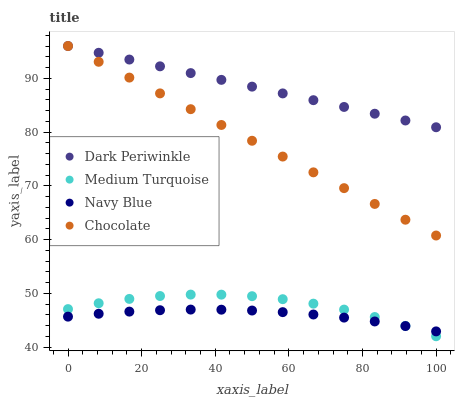Does Navy Blue have the minimum area under the curve?
Answer yes or no. Yes. Does Dark Periwinkle have the maximum area under the curve?
Answer yes or no. Yes. Does Medium Turquoise have the minimum area under the curve?
Answer yes or no. No. Does Medium Turquoise have the maximum area under the curve?
Answer yes or no. No. Is Dark Periwinkle the smoothest?
Answer yes or no. Yes. Is Medium Turquoise the roughest?
Answer yes or no. Yes. Is Medium Turquoise the smoothest?
Answer yes or no. No. Is Dark Periwinkle the roughest?
Answer yes or no. No. Does Medium Turquoise have the lowest value?
Answer yes or no. Yes. Does Dark Periwinkle have the lowest value?
Answer yes or no. No. Does Chocolate have the highest value?
Answer yes or no. Yes. Does Medium Turquoise have the highest value?
Answer yes or no. No. Is Navy Blue less than Dark Periwinkle?
Answer yes or no. Yes. Is Dark Periwinkle greater than Medium Turquoise?
Answer yes or no. Yes. Does Medium Turquoise intersect Navy Blue?
Answer yes or no. Yes. Is Medium Turquoise less than Navy Blue?
Answer yes or no. No. Is Medium Turquoise greater than Navy Blue?
Answer yes or no. No. Does Navy Blue intersect Dark Periwinkle?
Answer yes or no. No. 